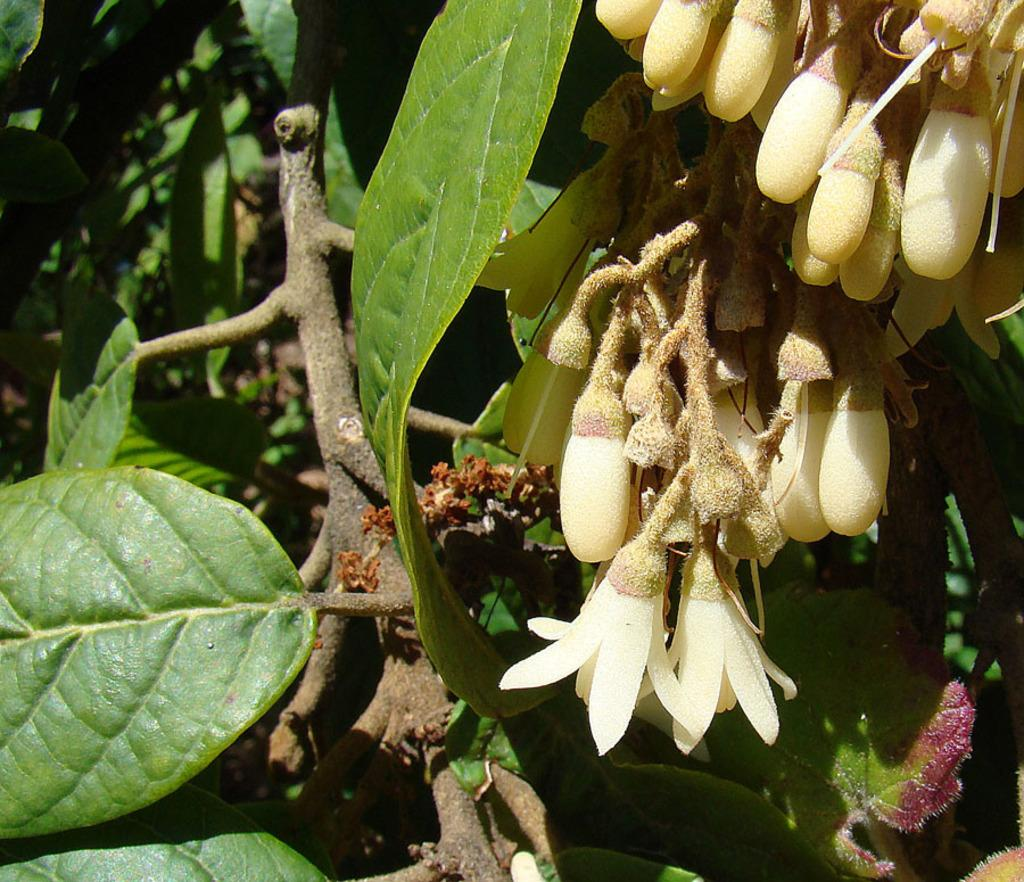What type of vegetation is present in the image? There are trees in the image. What features can be observed on the trees? The trees have flowers, buds, and leaves. How many cows are grazing under the trees in the image? There are no cows present in the image; it only features trees with flowers, buds, and leaves. 